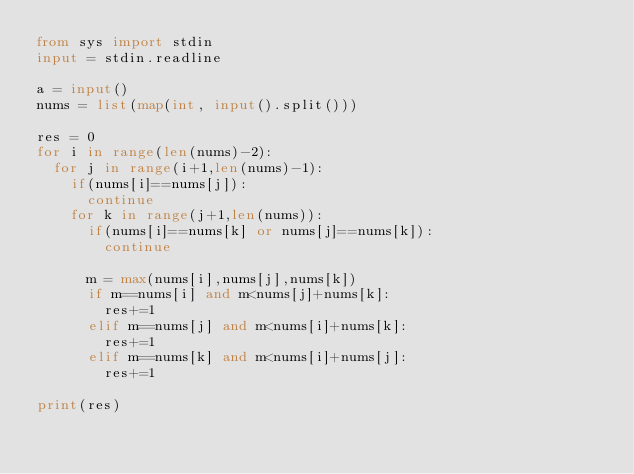Convert code to text. <code><loc_0><loc_0><loc_500><loc_500><_Python_>from sys import stdin
input = stdin.readline

a = input()
nums = list(map(int, input().split()))

res = 0
for i in range(len(nums)-2):
  for j in range(i+1,len(nums)-1):
    if(nums[i]==nums[j]):
      continue
    for k in range(j+1,len(nums)):
      if(nums[i]==nums[k] or nums[j]==nums[k]):
        continue
      
      m = max(nums[i],nums[j],nums[k])
      if m==nums[i] and m<nums[j]+nums[k]:
        res+=1
      elif m==nums[j] and m<nums[i]+nums[k]:
        res+=1
      elif m==nums[k] and m<nums[i]+nums[j]:
        res+=1

print(res)</code> 